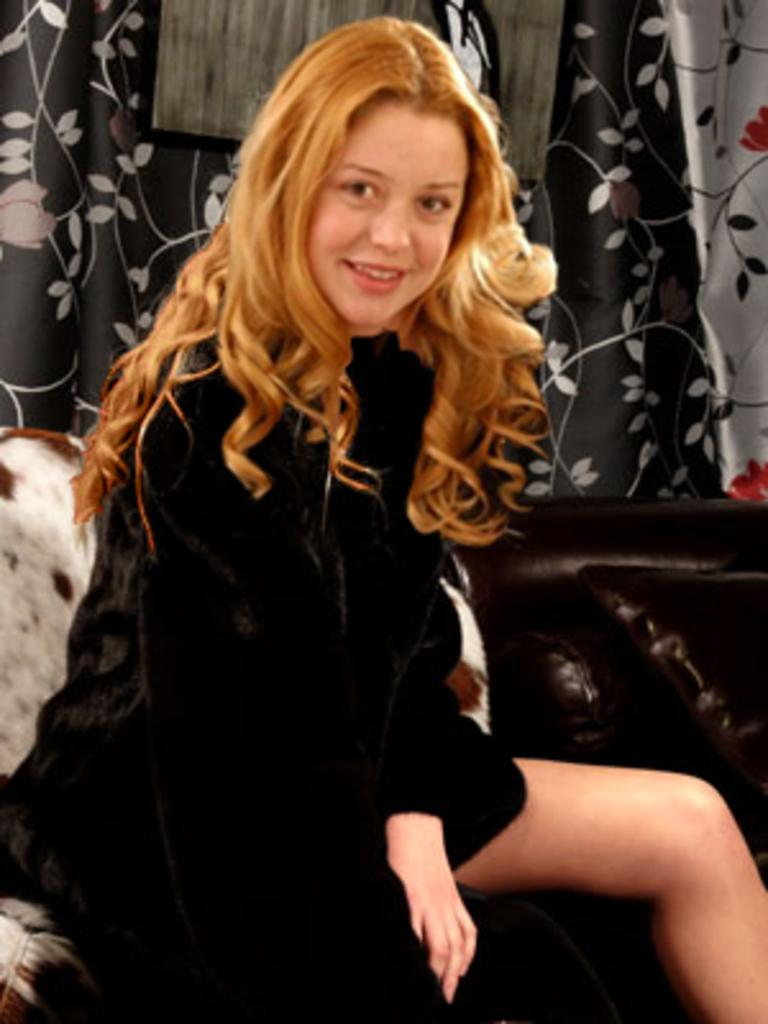Who is the main subject in the image? There is a lady in the image. What is the lady doing in the image? The lady is sitting in the image. What is the lady's facial expression in the image? The lady is smiling in the image. What is the lady wearing in the image? The lady is wearing a black dress in the image. What can be seen in the background of the image? There is a sofa and a curtain in the background of the image. What type of insurance does the lady have in the image? There is no information about the lady's insurance in the image. What time of day is the recess happening in the image? There is no recess or indication of time of day in the image. 